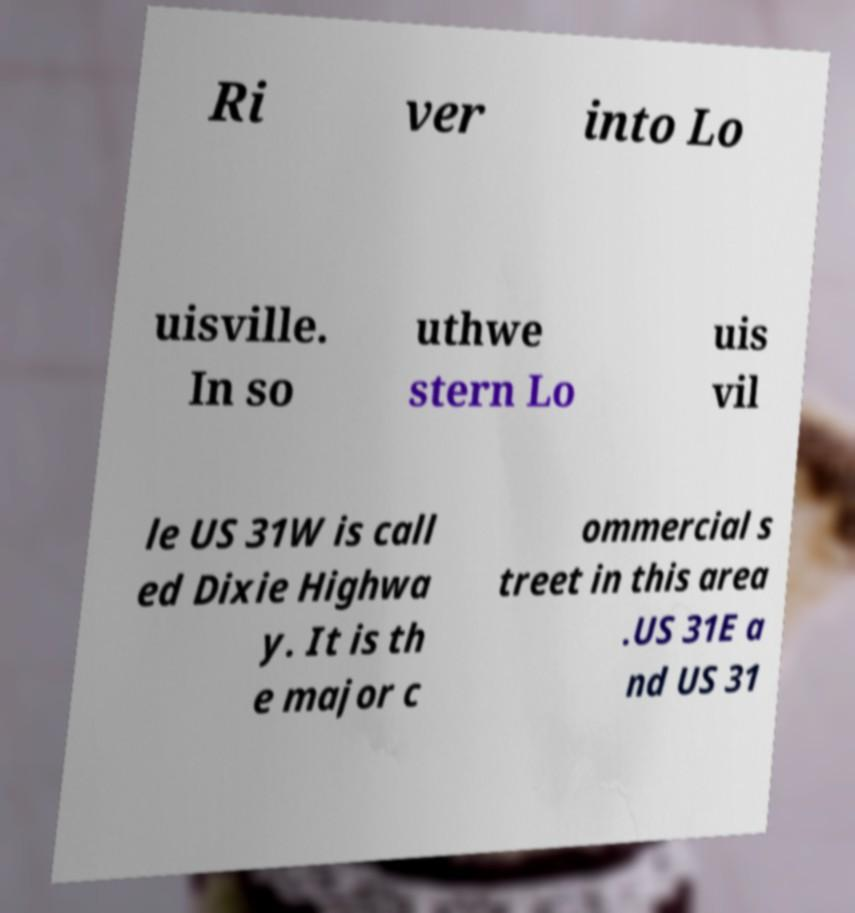Please identify and transcribe the text found in this image. Ri ver into Lo uisville. In so uthwe stern Lo uis vil le US 31W is call ed Dixie Highwa y. It is th e major c ommercial s treet in this area .US 31E a nd US 31 